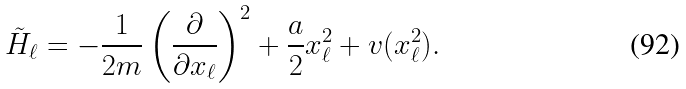Convert formula to latex. <formula><loc_0><loc_0><loc_500><loc_500>\tilde { H } _ { \ell } = - \frac { 1 } { 2 m } \left ( \frac { \partial } { \partial x _ { \ell } } \right ) ^ { 2 } + \frac { a } { 2 } x _ { \ell } ^ { 2 } + v ( x _ { \ell } ^ { 2 } ) .</formula> 